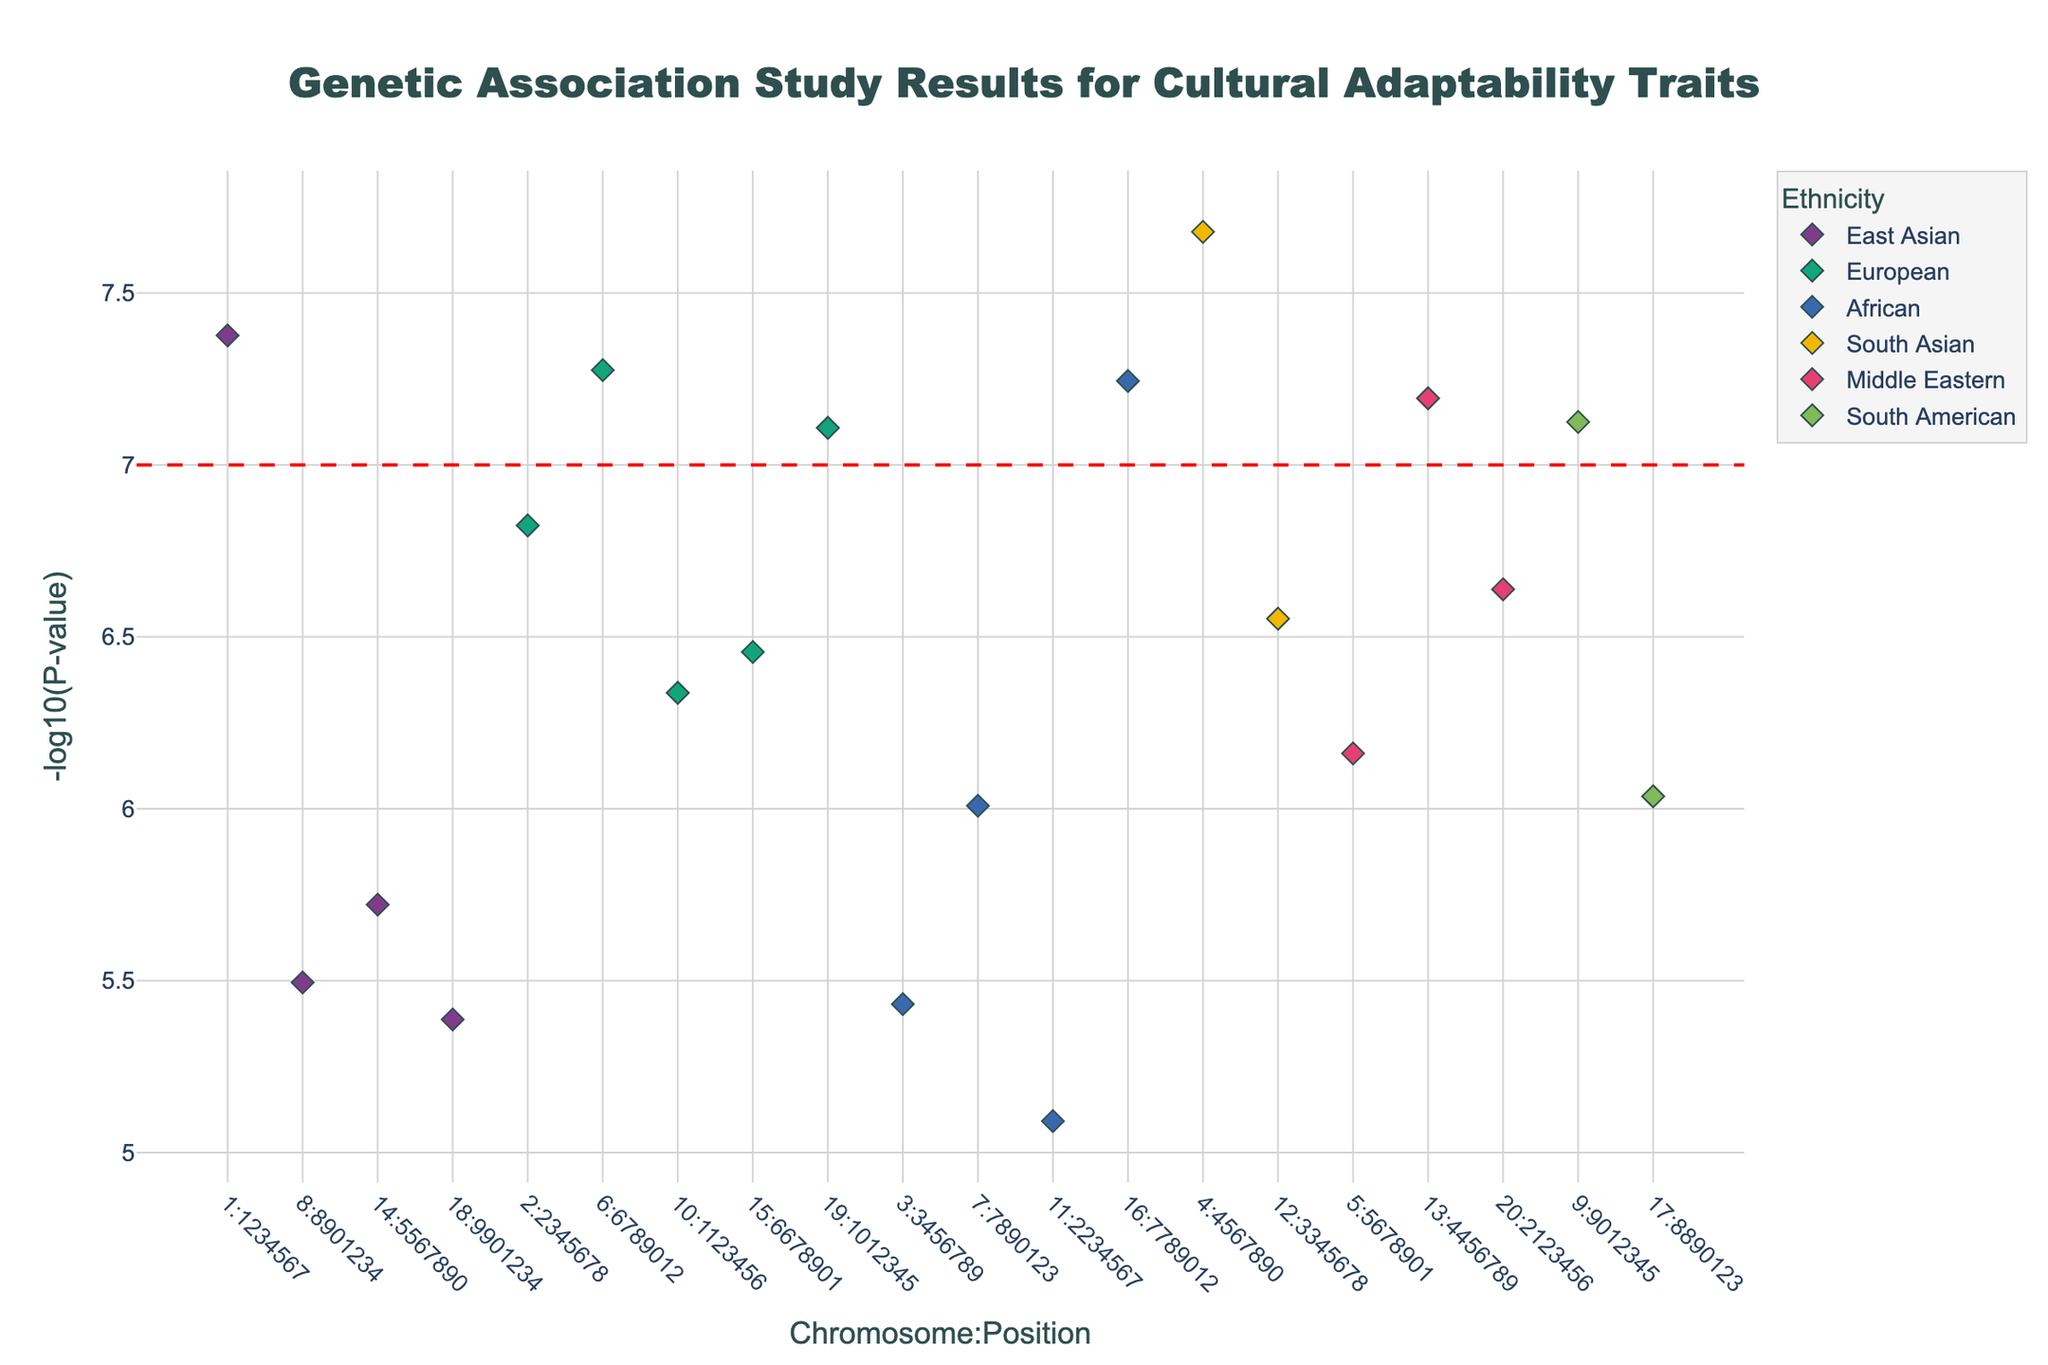What's the title of the plot? The title is usually displayed at the top center of the plot in a prominent font size, providing a quick summary of the plot's primary theme. Here, the plot title reads 'Genetic Association Study Results for Cultural Adaptability Traits'.
Answer: Genetic Association Study Results for Cultural Adaptability Traits What are the axes labels of the plot? Axes labels are essential for interpreting a plot. The x-axis typically describes the independent variable, and the y-axis describes the dependent variable. In this Manhattan Plot, the x-axis is labeled 'Chromosome:Position', representing the genomic location of each SNP, and the y-axis is labeled '-log10(P-value)', representing the statistical significance of the association.
Answer: Chromosome:Position and -log10(P-value) How many SNPs achieve a significance level of 5e-8 (denoted by the horizontal red line) or lower in raw p-value (i.e., -log10(p-value) of 7 or higher)? The Manhattan Plot includes a dashed red horizontal line at y = 7. SNPs above this line have -log10(p-value) values of 7 or higher, indicating high significance. By counting the data points above the line, one can tally the number of significant SNPs. There are 7 such SNPs.
Answer: 7 Which SNP has the highest -log10(P-value) and to which ethnicity does it belong? To find the SNP with the highest -log10(P-value), look for the data point that is highest on the y-axis. According to the data, the SNP with the maximum -log10(P-value) is rs2289311, with a value of 7.38. It is associated with East Asian ethnicity.
Answer: rs2289311, East Asian Which trait is most significantly associated with East Asian ethnicity? To determine this, scan for the data point with the highest -log10(P-value) within the East Asian ethnic group. The highest point for East Asian is rs2289311, which is associated with the trait 'Openness to Experience'.
Answer: Openness to Experience Across all ethnicities, which trait appears most frequently in significant SNPs (above the threshold)? This requires checking traits mapped to SNPs above the significance threshold of -log10(P-value) = 7, and counting the occurrences. The values above the threshold are associated with the traits: Openness to Experience, Cultural Intelligence, Cross-cultural Communication, Cultural Flexibility, Global Citizenship, Multilingual Aptitude, and Cultural Tolerance. Each appears once, so no trait is more frequent than others.
Answer: Each appears once Which ethnicity has the most SNPs represented on the plot? This involves counting the number of unique data points for each ethnicity in the plot. European ethnicity has the highest number of SNPs depicted in the plot.
Answer: European What trait is associated with the SNP located at Chromosome 4, position 4567890? To find this, look for the SNP corresponding to Chromosome 4 at position 4567890. The plot or the data table shows that this SNP (rs53576) is associated with the trait 'Cross-cultural Communication'.
Answer: Cross-cultural Communication Among the SNPs significant at the 5e-8 threshold, which SNP is associated with African ethnicity and what is its trait? First, identify all SNPs above the 5e-8 significance threshold (y-axis above 7). Next, filter for SNPs belonging to the African ethnicity. The SNP rs4680 with an associated trait 'Multilingual Aptitude' meets these criteria.
Answer: rs4680, Multilingual Aptitude Which two ethnicities show a significant association with Cultural Empathy and Cultural Intelligence, and what are their respective SNPs? Examining the data, Cultural Empathy is associated with rs4680 in European ethnicity, and Cultural Intelligence is associated with rs6265 in European ethnicity. Both traits are linked to the same ethnicity.
Answer: European, rs4680 for Cultural Empathy and rs6265 for Cultural Intelligence 